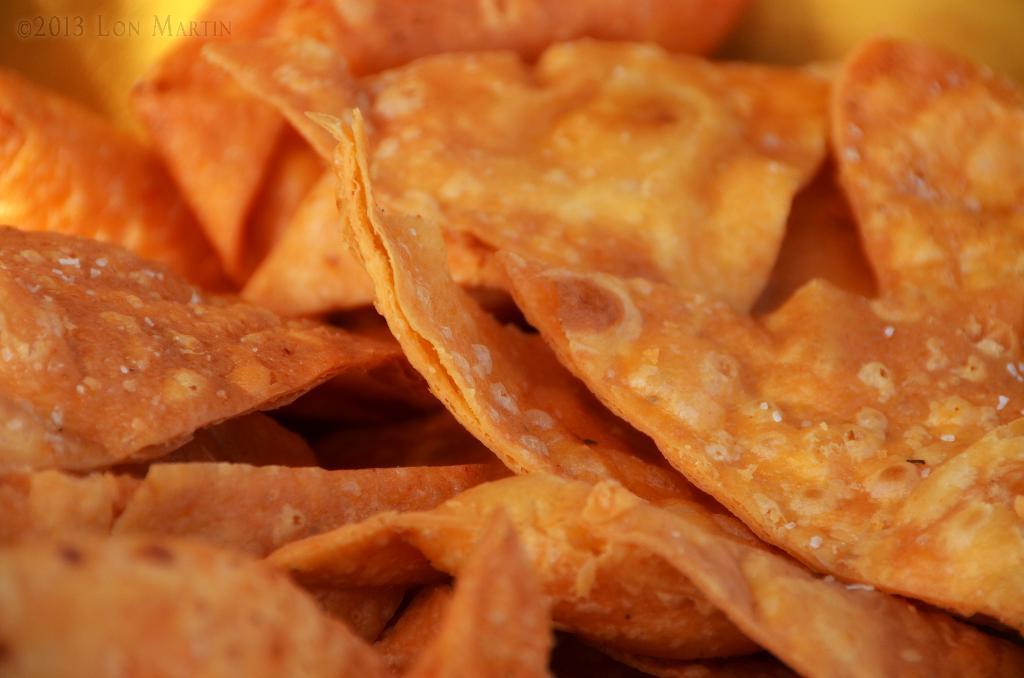How would you summarize this image in a sentence or two? In this image there is food item, on the top left there is text. 